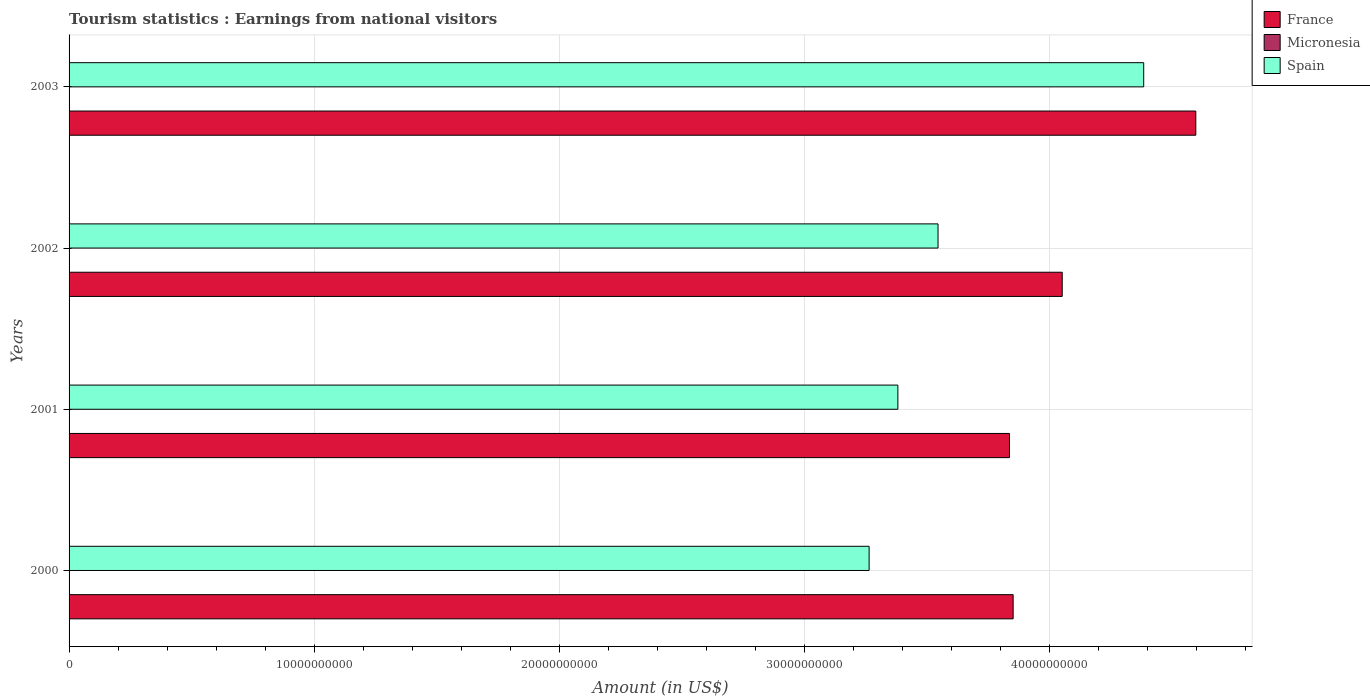Are the number of bars on each tick of the Y-axis equal?
Your answer should be compact. Yes. How many bars are there on the 1st tick from the top?
Provide a short and direct response. 3. In how many cases, is the number of bars for a given year not equal to the number of legend labels?
Ensure brevity in your answer.  0. What is the earnings from national visitors in France in 2000?
Provide a succinct answer. 3.85e+1. Across all years, what is the maximum earnings from national visitors in France?
Offer a terse response. 4.60e+1. Across all years, what is the minimum earnings from national visitors in Spain?
Give a very brief answer. 3.27e+1. In which year was the earnings from national visitors in France maximum?
Keep it short and to the point. 2003. What is the total earnings from national visitors in Spain in the graph?
Ensure brevity in your answer.  1.46e+11. What is the difference between the earnings from national visitors in Spain in 2002 and that in 2003?
Provide a short and direct response. -8.40e+09. What is the difference between the earnings from national visitors in Spain in 2000 and the earnings from national visitors in Micronesia in 2002?
Make the answer very short. 3.26e+1. What is the average earnings from national visitors in France per year?
Provide a succinct answer. 4.09e+1. In the year 2002, what is the difference between the earnings from national visitors in France and earnings from national visitors in Spain?
Keep it short and to the point. 5.07e+09. What is the ratio of the earnings from national visitors in France in 2000 to that in 2003?
Your answer should be compact. 0.84. Is the earnings from national visitors in Micronesia in 2000 less than that in 2001?
Your answer should be compact. No. Is the difference between the earnings from national visitors in France in 2001 and 2002 greater than the difference between the earnings from national visitors in Spain in 2001 and 2002?
Your answer should be very brief. No. What is the difference between the highest and the lowest earnings from national visitors in Spain?
Your answer should be compact. 1.12e+1. In how many years, is the earnings from national visitors in France greater than the average earnings from national visitors in France taken over all years?
Offer a very short reply. 1. What does the 3rd bar from the top in 2002 represents?
Ensure brevity in your answer.  France. What does the 2nd bar from the bottom in 2000 represents?
Provide a succinct answer. Micronesia. Is it the case that in every year, the sum of the earnings from national visitors in Spain and earnings from national visitors in Micronesia is greater than the earnings from national visitors in France?
Give a very brief answer. No. Are all the bars in the graph horizontal?
Offer a terse response. Yes. How many legend labels are there?
Make the answer very short. 3. What is the title of the graph?
Give a very brief answer. Tourism statistics : Earnings from national visitors. What is the label or title of the X-axis?
Offer a terse response. Amount (in US$). What is the Amount (in US$) of France in 2000?
Offer a very short reply. 3.85e+1. What is the Amount (in US$) of Micronesia in 2000?
Offer a very short reply. 1.70e+07. What is the Amount (in US$) in Spain in 2000?
Your answer should be compact. 3.27e+1. What is the Amount (in US$) of France in 2001?
Offer a very short reply. 3.84e+1. What is the Amount (in US$) of Micronesia in 2001?
Your response must be concise. 1.50e+07. What is the Amount (in US$) of Spain in 2001?
Keep it short and to the point. 3.38e+1. What is the Amount (in US$) in France in 2002?
Your answer should be compact. 4.05e+1. What is the Amount (in US$) in Micronesia in 2002?
Offer a very short reply. 1.70e+07. What is the Amount (in US$) in Spain in 2002?
Keep it short and to the point. 3.55e+1. What is the Amount (in US$) of France in 2003?
Make the answer very short. 4.60e+1. What is the Amount (in US$) in Micronesia in 2003?
Give a very brief answer. 1.70e+07. What is the Amount (in US$) in Spain in 2003?
Provide a succinct answer. 4.39e+1. Across all years, what is the maximum Amount (in US$) of France?
Ensure brevity in your answer.  4.60e+1. Across all years, what is the maximum Amount (in US$) in Micronesia?
Your response must be concise. 1.70e+07. Across all years, what is the maximum Amount (in US$) of Spain?
Your response must be concise. 4.39e+1. Across all years, what is the minimum Amount (in US$) in France?
Give a very brief answer. 3.84e+1. Across all years, what is the minimum Amount (in US$) of Micronesia?
Offer a very short reply. 1.50e+07. Across all years, what is the minimum Amount (in US$) in Spain?
Your answer should be compact. 3.27e+1. What is the total Amount (in US$) of France in the graph?
Your answer should be compact. 1.63e+11. What is the total Amount (in US$) in Micronesia in the graph?
Offer a very short reply. 6.60e+07. What is the total Amount (in US$) in Spain in the graph?
Give a very brief answer. 1.46e+11. What is the difference between the Amount (in US$) in France in 2000 and that in 2001?
Offer a very short reply. 1.49e+08. What is the difference between the Amount (in US$) of Micronesia in 2000 and that in 2001?
Your answer should be very brief. 2.00e+06. What is the difference between the Amount (in US$) of Spain in 2000 and that in 2001?
Offer a very short reply. -1.17e+09. What is the difference between the Amount (in US$) in France in 2000 and that in 2002?
Provide a short and direct response. -2.00e+09. What is the difference between the Amount (in US$) in Micronesia in 2000 and that in 2002?
Ensure brevity in your answer.  0. What is the difference between the Amount (in US$) of Spain in 2000 and that in 2002?
Offer a very short reply. -2.81e+09. What is the difference between the Amount (in US$) in France in 2000 and that in 2003?
Your answer should be compact. -7.46e+09. What is the difference between the Amount (in US$) in Spain in 2000 and that in 2003?
Your response must be concise. -1.12e+1. What is the difference between the Amount (in US$) in France in 2001 and that in 2002?
Provide a succinct answer. -2.15e+09. What is the difference between the Amount (in US$) of Spain in 2001 and that in 2002?
Offer a very short reply. -1.64e+09. What is the difference between the Amount (in US$) of France in 2001 and that in 2003?
Your answer should be very brief. -7.60e+09. What is the difference between the Amount (in US$) of Spain in 2001 and that in 2003?
Provide a short and direct response. -1.00e+1. What is the difference between the Amount (in US$) of France in 2002 and that in 2003?
Keep it short and to the point. -5.45e+09. What is the difference between the Amount (in US$) of Micronesia in 2002 and that in 2003?
Provide a succinct answer. 0. What is the difference between the Amount (in US$) of Spain in 2002 and that in 2003?
Make the answer very short. -8.40e+09. What is the difference between the Amount (in US$) of France in 2000 and the Amount (in US$) of Micronesia in 2001?
Make the answer very short. 3.85e+1. What is the difference between the Amount (in US$) of France in 2000 and the Amount (in US$) of Spain in 2001?
Provide a succinct answer. 4.70e+09. What is the difference between the Amount (in US$) of Micronesia in 2000 and the Amount (in US$) of Spain in 2001?
Make the answer very short. -3.38e+1. What is the difference between the Amount (in US$) of France in 2000 and the Amount (in US$) of Micronesia in 2002?
Make the answer very short. 3.85e+1. What is the difference between the Amount (in US$) in France in 2000 and the Amount (in US$) in Spain in 2002?
Your response must be concise. 3.07e+09. What is the difference between the Amount (in US$) in Micronesia in 2000 and the Amount (in US$) in Spain in 2002?
Offer a terse response. -3.55e+1. What is the difference between the Amount (in US$) in France in 2000 and the Amount (in US$) in Micronesia in 2003?
Give a very brief answer. 3.85e+1. What is the difference between the Amount (in US$) of France in 2000 and the Amount (in US$) of Spain in 2003?
Provide a short and direct response. -5.33e+09. What is the difference between the Amount (in US$) in Micronesia in 2000 and the Amount (in US$) in Spain in 2003?
Your response must be concise. -4.38e+1. What is the difference between the Amount (in US$) in France in 2001 and the Amount (in US$) in Micronesia in 2002?
Provide a short and direct response. 3.84e+1. What is the difference between the Amount (in US$) in France in 2001 and the Amount (in US$) in Spain in 2002?
Provide a short and direct response. 2.92e+09. What is the difference between the Amount (in US$) of Micronesia in 2001 and the Amount (in US$) of Spain in 2002?
Ensure brevity in your answer.  -3.55e+1. What is the difference between the Amount (in US$) in France in 2001 and the Amount (in US$) in Micronesia in 2003?
Provide a short and direct response. 3.84e+1. What is the difference between the Amount (in US$) in France in 2001 and the Amount (in US$) in Spain in 2003?
Provide a short and direct response. -5.48e+09. What is the difference between the Amount (in US$) in Micronesia in 2001 and the Amount (in US$) in Spain in 2003?
Make the answer very short. -4.38e+1. What is the difference between the Amount (in US$) in France in 2002 and the Amount (in US$) in Micronesia in 2003?
Ensure brevity in your answer.  4.05e+1. What is the difference between the Amount (in US$) in France in 2002 and the Amount (in US$) in Spain in 2003?
Your response must be concise. -3.33e+09. What is the difference between the Amount (in US$) of Micronesia in 2002 and the Amount (in US$) of Spain in 2003?
Your answer should be compact. -4.38e+1. What is the average Amount (in US$) of France per year?
Make the answer very short. 4.09e+1. What is the average Amount (in US$) of Micronesia per year?
Your answer should be very brief. 1.65e+07. What is the average Amount (in US$) of Spain per year?
Your response must be concise. 3.65e+1. In the year 2000, what is the difference between the Amount (in US$) of France and Amount (in US$) of Micronesia?
Keep it short and to the point. 3.85e+1. In the year 2000, what is the difference between the Amount (in US$) in France and Amount (in US$) in Spain?
Give a very brief answer. 5.88e+09. In the year 2000, what is the difference between the Amount (in US$) in Micronesia and Amount (in US$) in Spain?
Give a very brief answer. -3.26e+1. In the year 2001, what is the difference between the Amount (in US$) in France and Amount (in US$) in Micronesia?
Your answer should be compact. 3.84e+1. In the year 2001, what is the difference between the Amount (in US$) of France and Amount (in US$) of Spain?
Give a very brief answer. 4.56e+09. In the year 2001, what is the difference between the Amount (in US$) in Micronesia and Amount (in US$) in Spain?
Provide a succinct answer. -3.38e+1. In the year 2002, what is the difference between the Amount (in US$) of France and Amount (in US$) of Micronesia?
Your response must be concise. 4.05e+1. In the year 2002, what is the difference between the Amount (in US$) of France and Amount (in US$) of Spain?
Your answer should be compact. 5.07e+09. In the year 2002, what is the difference between the Amount (in US$) of Micronesia and Amount (in US$) of Spain?
Keep it short and to the point. -3.55e+1. In the year 2003, what is the difference between the Amount (in US$) of France and Amount (in US$) of Micronesia?
Your answer should be compact. 4.60e+1. In the year 2003, what is the difference between the Amount (in US$) in France and Amount (in US$) in Spain?
Offer a very short reply. 2.13e+09. In the year 2003, what is the difference between the Amount (in US$) of Micronesia and Amount (in US$) of Spain?
Ensure brevity in your answer.  -4.38e+1. What is the ratio of the Amount (in US$) of Micronesia in 2000 to that in 2001?
Provide a succinct answer. 1.13. What is the ratio of the Amount (in US$) of Spain in 2000 to that in 2001?
Provide a succinct answer. 0.97. What is the ratio of the Amount (in US$) in France in 2000 to that in 2002?
Ensure brevity in your answer.  0.95. What is the ratio of the Amount (in US$) in Spain in 2000 to that in 2002?
Give a very brief answer. 0.92. What is the ratio of the Amount (in US$) in France in 2000 to that in 2003?
Provide a short and direct response. 0.84. What is the ratio of the Amount (in US$) of Micronesia in 2000 to that in 2003?
Offer a terse response. 1. What is the ratio of the Amount (in US$) of Spain in 2000 to that in 2003?
Keep it short and to the point. 0.74. What is the ratio of the Amount (in US$) of France in 2001 to that in 2002?
Give a very brief answer. 0.95. What is the ratio of the Amount (in US$) in Micronesia in 2001 to that in 2002?
Offer a very short reply. 0.88. What is the ratio of the Amount (in US$) of Spain in 2001 to that in 2002?
Your answer should be compact. 0.95. What is the ratio of the Amount (in US$) in France in 2001 to that in 2003?
Your answer should be very brief. 0.83. What is the ratio of the Amount (in US$) in Micronesia in 2001 to that in 2003?
Provide a succinct answer. 0.88. What is the ratio of the Amount (in US$) of Spain in 2001 to that in 2003?
Provide a short and direct response. 0.77. What is the ratio of the Amount (in US$) in France in 2002 to that in 2003?
Your answer should be compact. 0.88. What is the ratio of the Amount (in US$) of Micronesia in 2002 to that in 2003?
Your answer should be very brief. 1. What is the ratio of the Amount (in US$) of Spain in 2002 to that in 2003?
Give a very brief answer. 0.81. What is the difference between the highest and the second highest Amount (in US$) in France?
Your answer should be very brief. 5.45e+09. What is the difference between the highest and the second highest Amount (in US$) of Micronesia?
Make the answer very short. 0. What is the difference between the highest and the second highest Amount (in US$) in Spain?
Ensure brevity in your answer.  8.40e+09. What is the difference between the highest and the lowest Amount (in US$) of France?
Your response must be concise. 7.60e+09. What is the difference between the highest and the lowest Amount (in US$) in Spain?
Your answer should be very brief. 1.12e+1. 